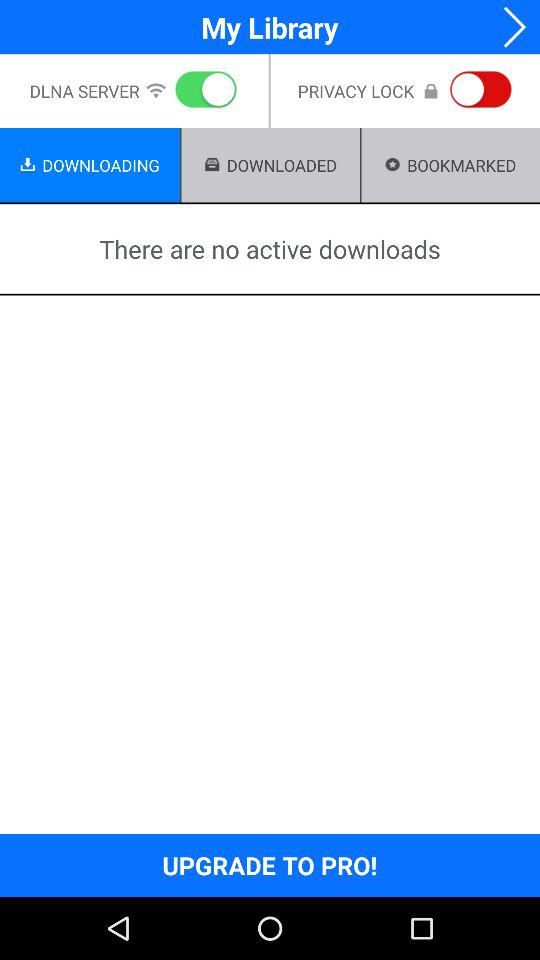Which tab has been selected? The tab "DOWNLOADING" has been selected. 